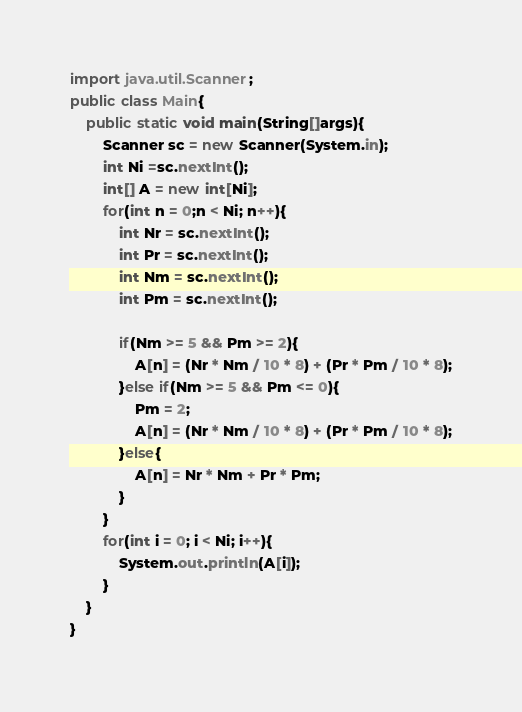<code> <loc_0><loc_0><loc_500><loc_500><_Java_>import java.util.Scanner;
public class Main{
	public static void main(String[]args){
		Scanner sc = new Scanner(System.in);
		int Ni =sc.nextInt();
		int[] A = new int[Ni];
		for(int n = 0;n < Ni; n++){
			int Nr = sc.nextInt();
			int Pr = sc.nextInt();
			int Nm = sc.nextInt();
			int Pm = sc.nextInt();
			
			if(Nm >= 5 && Pm >= 2){
				A[n] = (Nr * Nm / 10 * 8) + (Pr * Pm / 10 * 8);
			}else if(Nm >= 5 && Pm <= 0){
				Pm = 2;
				A[n] = (Nr * Nm / 10 * 8) + (Pr * Pm / 10 * 8);
			}else{
				A[n] = Nr * Nm + Pr * Pm;
			}
		}
		for(int i = 0; i < Ni; i++){
			System.out.println(A[i]);
		}
	}
}</code> 